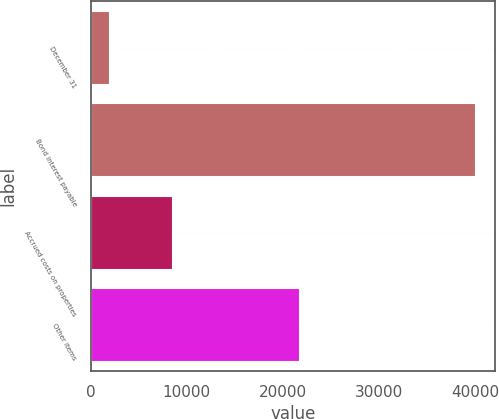Convert chart. <chart><loc_0><loc_0><loc_500><loc_500><bar_chart><fcel>December 31<fcel>Bond interest payable<fcel>Accrued costs on properties<fcel>Other items<nl><fcel>2012<fcel>40061<fcel>8595<fcel>21770<nl></chart> 